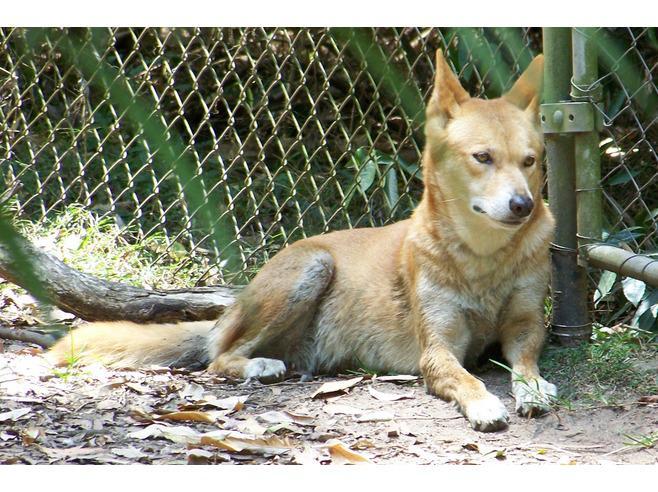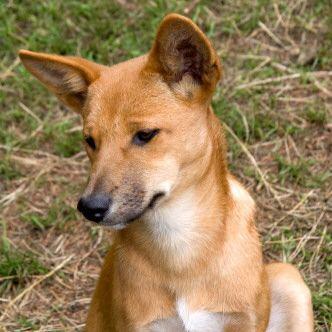The first image is the image on the left, the second image is the image on the right. Considering the images on both sides, is "The left image shows one reclining dog with extened front paws and upright head, and the right image shows one orange dingo gazing leftward." valid? Answer yes or no. Yes. 